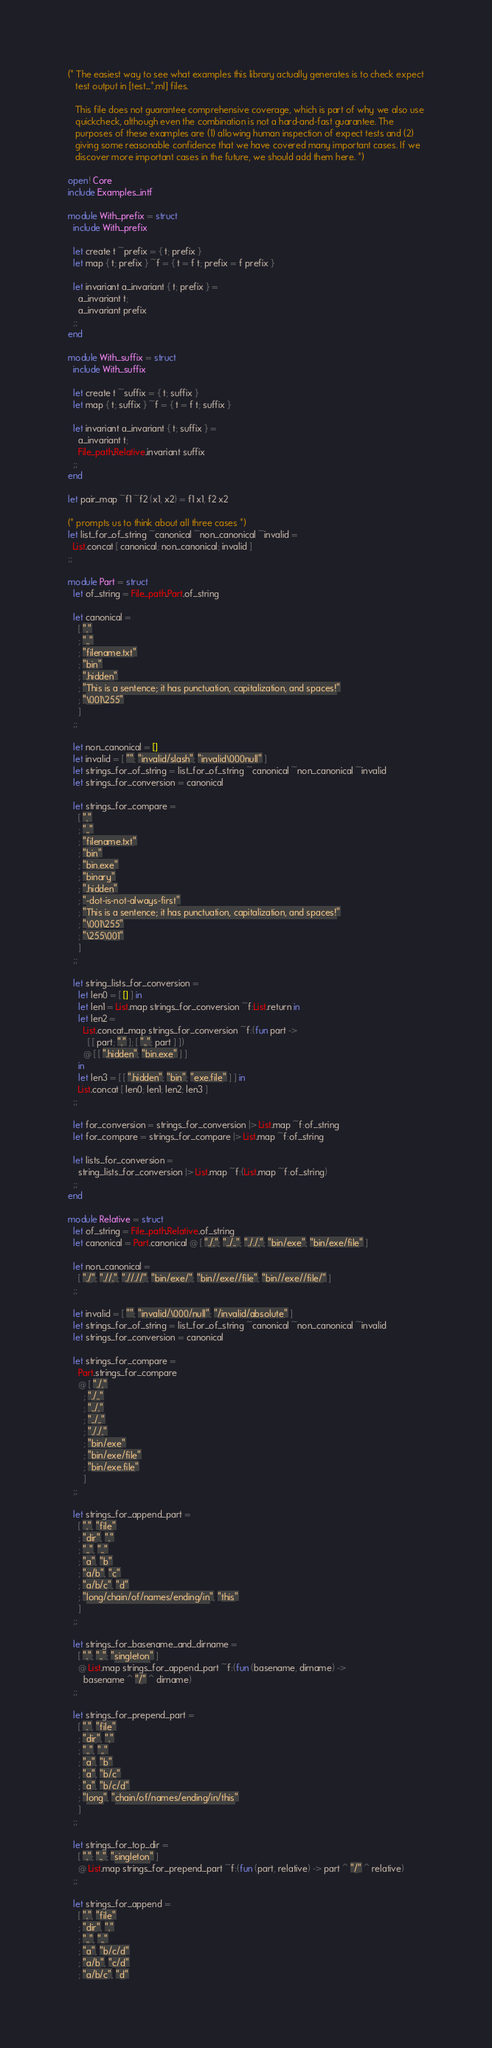Convert code to text. <code><loc_0><loc_0><loc_500><loc_500><_OCaml_>(* The easiest way to see what examples this library actually generates is to check expect
   test output in [test_*.ml] files.

   This file does not guarantee comprehensive coverage, which is part of why we also use
   quickcheck, although even the combination is not a hard-and-fast guarantee. The
   purposes of these examples are (1) allowing human inspection of expect tests and (2)
   giving some reasonable confidence that we have covered many important cases. If we
   discover more important cases in the future, we should add them here. *)

open! Core
include Examples_intf

module With_prefix = struct
  include With_prefix

  let create t ~prefix = { t; prefix }
  let map { t; prefix } ~f = { t = f t; prefix = f prefix }

  let invariant a_invariant { t; prefix } =
    a_invariant t;
    a_invariant prefix
  ;;
end

module With_suffix = struct
  include With_suffix

  let create t ~suffix = { t; suffix }
  let map { t; suffix } ~f = { t = f t; suffix }

  let invariant a_invariant { t; suffix } =
    a_invariant t;
    File_path.Relative.invariant suffix
  ;;
end

let pair_map ~f1 ~f2 (x1, x2) = f1 x1, f2 x2

(* prompts us to think about all three cases *)
let list_for_of_string ~canonical ~non_canonical ~invalid =
  List.concat [ canonical; non_canonical; invalid ]
;;

module Part = struct
  let of_string = File_path.Part.of_string

  let canonical =
    [ "."
    ; ".."
    ; "filename.txt"
    ; "bin"
    ; ".hidden"
    ; "This is a sentence; it has punctuation, capitalization, and spaces!"
    ; "\001\255"
    ]
  ;;

  let non_canonical = []
  let invalid = [ ""; "invalid/slash"; "invalid\000null" ]
  let strings_for_of_string = list_for_of_string ~canonical ~non_canonical ~invalid
  let strings_for_conversion = canonical

  let strings_for_compare =
    [ "."
    ; ".."
    ; "filename.txt"
    ; "bin"
    ; "bin.exe"
    ; "binary"
    ; ".hidden"
    ; "-dot-is-not-always-first"
    ; "This is a sentence; it has punctuation, capitalization, and spaces!"
    ; "\001\255"
    ; "\255\001"
    ]
  ;;

  let string_lists_for_conversion =
    let len0 = [ [] ] in
    let len1 = List.map strings_for_conversion ~f:List.return in
    let len2 =
      List.concat_map strings_for_conversion ~f:(fun part ->
        [ [ part; "." ]; [ ".."; part ] ])
      @ [ [ ".hidden"; "bin.exe" ] ]
    in
    let len3 = [ [ ".hidden"; "bin"; "exe.file" ] ] in
    List.concat [ len0; len1; len2; len3 ]
  ;;

  let for_conversion = strings_for_conversion |> List.map ~f:of_string
  let for_compare = strings_for_compare |> List.map ~f:of_string

  let lists_for_conversion =
    string_lists_for_conversion |> List.map ~f:(List.map ~f:of_string)
  ;;
end

module Relative = struct
  let of_string = File_path.Relative.of_string
  let canonical = Part.canonical @ [ "./."; "../.."; "././."; "bin/exe"; "bin/exe/file" ]

  let non_canonical =
    [ "./"; ".//."; ".//.//"; "bin/exe/"; "bin//exe//file"; "bin//exe//file/" ]
  ;;

  let invalid = [ ""; "invalid/\000/null"; "/invalid/absolute" ]
  let strings_for_of_string = list_for_of_string ~canonical ~non_canonical ~invalid
  let strings_for_conversion = canonical

  let strings_for_compare =
    Part.strings_for_compare
    @ [ "./."
      ; "./.."
      ; "../."
      ; "../.."
      ; "././."
      ; "bin/exe"
      ; "bin/exe/file"
      ; "bin/exe.file"
      ]
  ;;

  let strings_for_append_part =
    [ ".", "file"
    ; "dir", "."
    ; "..", ".."
    ; "a", "b"
    ; "a/b", "c"
    ; "a/b/c", "d"
    ; "long/chain/of/names/ending/in", "this"
    ]
  ;;

  let strings_for_basename_and_dirname =
    [ "."; ".."; "singleton" ]
    @ List.map strings_for_append_part ~f:(fun (basename, dirname) ->
      basename ^ "/" ^ dirname)
  ;;

  let strings_for_prepend_part =
    [ ".", "file"
    ; "dir", "."
    ; "..", ".."
    ; "a", "b"
    ; "a", "b/c"
    ; "a", "b/c/d"
    ; "long", "chain/of/names/ending/in/this"
    ]
  ;;

  let strings_for_top_dir =
    [ "."; ".."; "singleton" ]
    @ List.map strings_for_prepend_part ~f:(fun (part, relative) -> part ^ "/" ^ relative)
  ;;

  let strings_for_append =
    [ ".", "file"
    ; "dir", "."
    ; "..", ".."
    ; "a", "b/c/d"
    ; "a/b", "c/d"
    ; "a/b/c", "d"</code> 